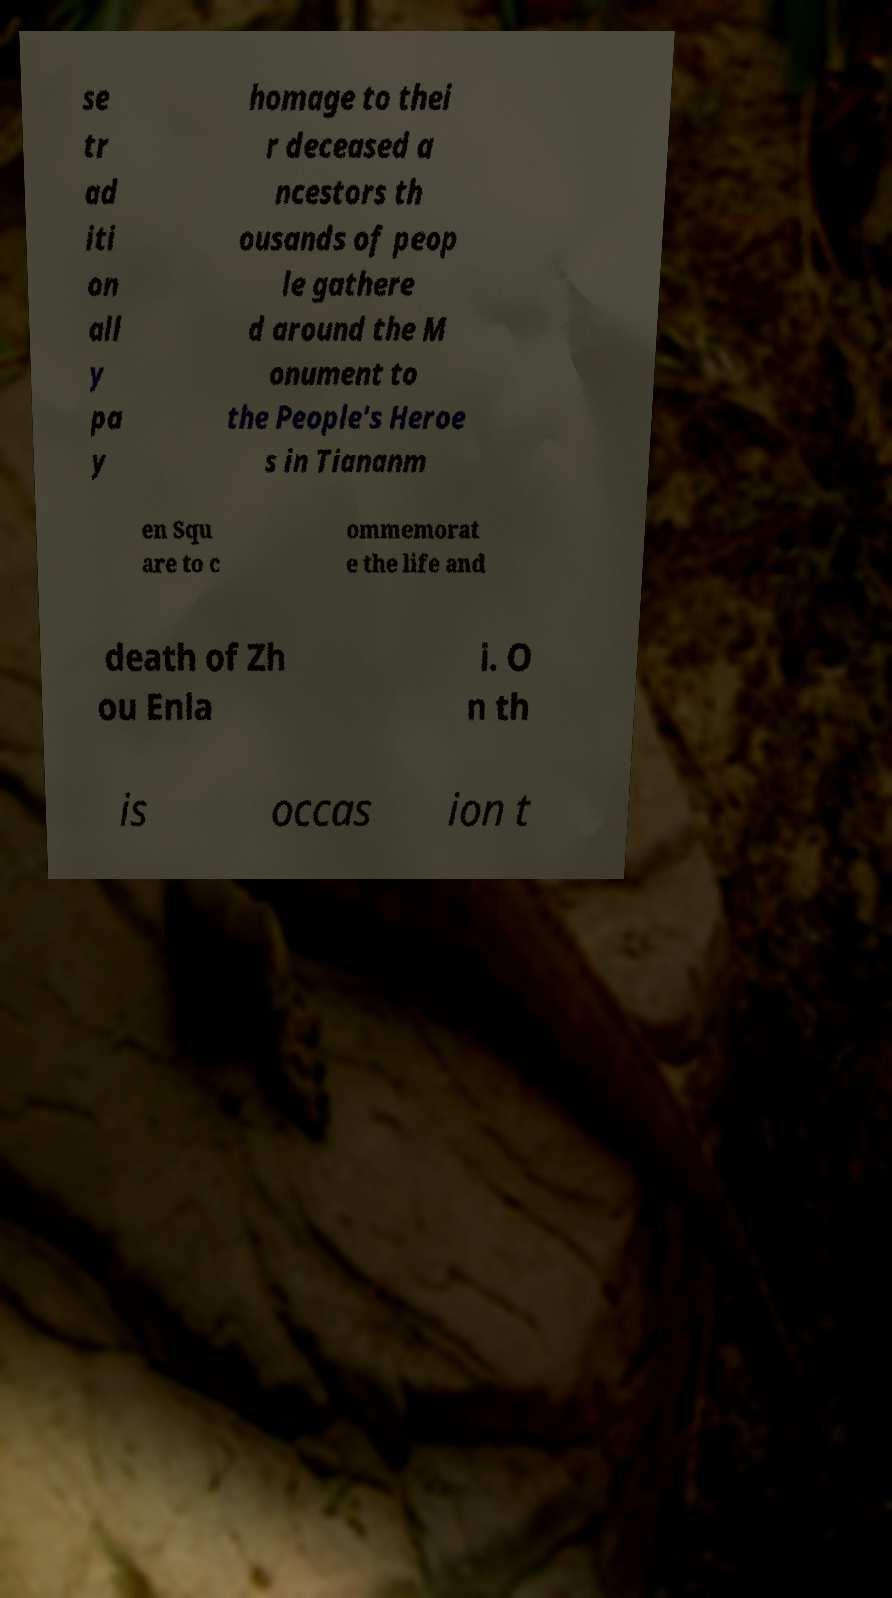Could you assist in decoding the text presented in this image and type it out clearly? se tr ad iti on all y pa y homage to thei r deceased a ncestors th ousands of peop le gathere d around the M onument to the People's Heroe s in Tiananm en Squ are to c ommemorat e the life and death of Zh ou Enla i. O n th is occas ion t 